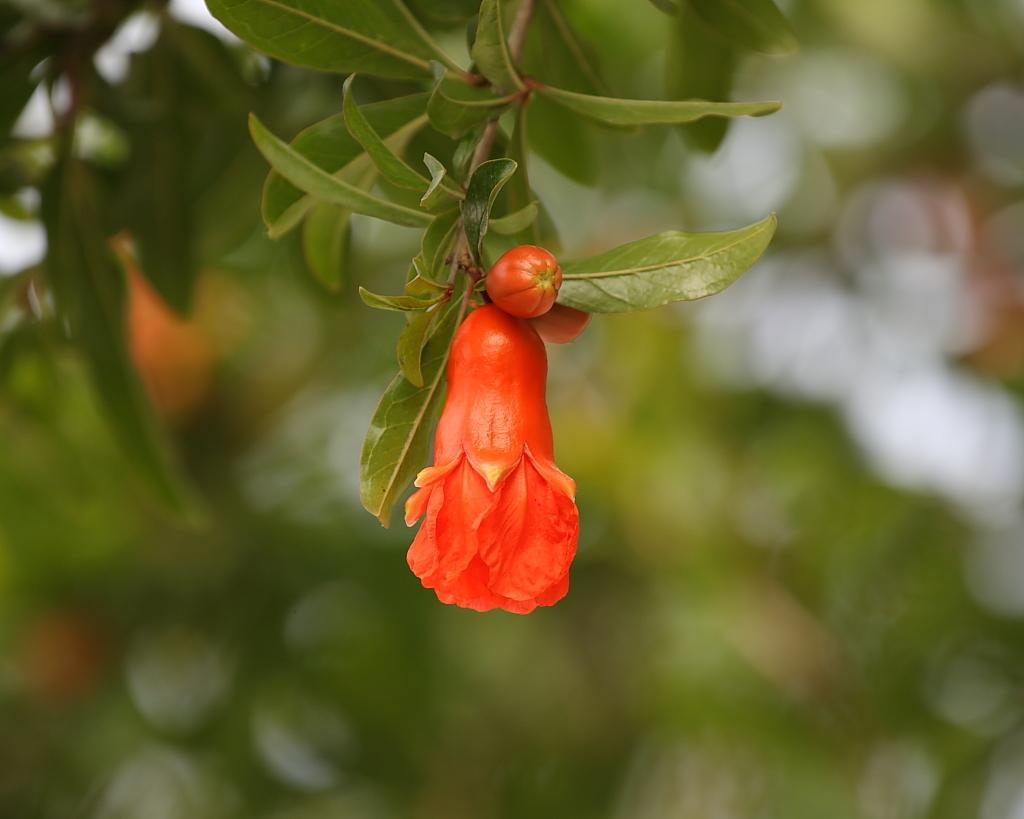What is the main subject of the picture? The main subject of the picture is a branch of a flowering plant. What can be seen on the branch? There is a flower and a bud of a flower on the branch. What is the color of the leaves on the branch? The leaves on the branch are green. What type of smoke can be seen coming from the flower in the image? There is no smoke present in the image; it features a branch with a flower and a bud. Is there a band playing music in the background of the image? There is no band or music present in the image; it focuses solely on the branch of a flowering plant. 